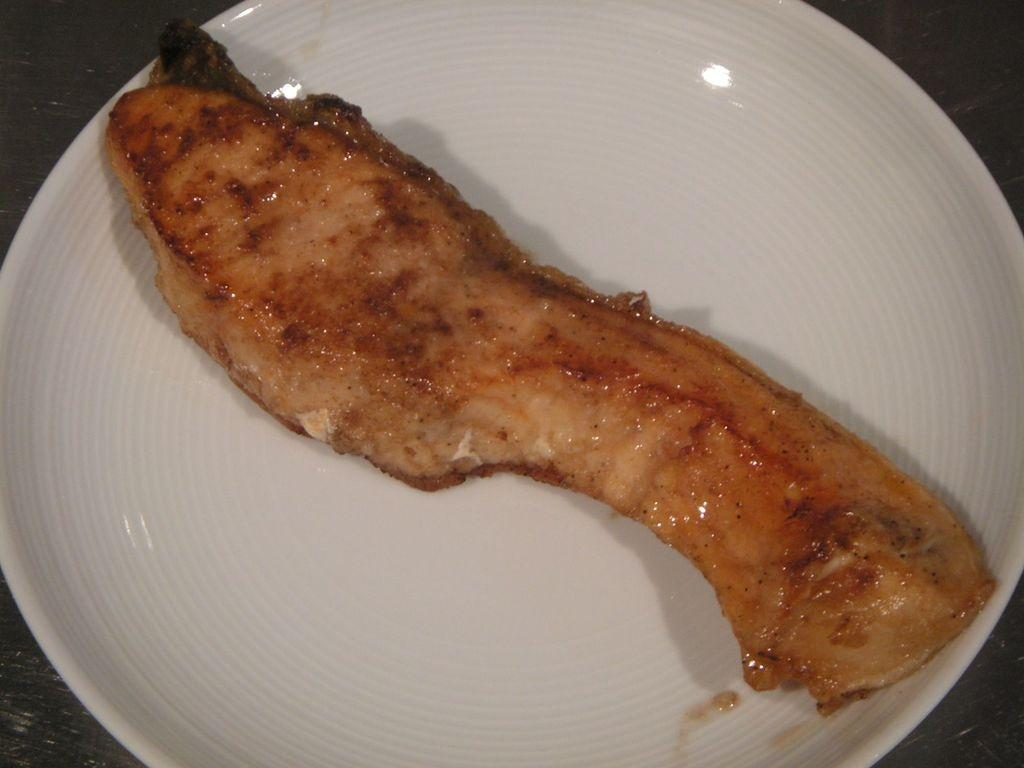What is on the plate in the image? There is a food item on a plate in the image. What color is the plate? The plate is white in color. What is the color of the surface the plate is on? The plate is on a dark color surface. How many stockings are hanging from the table in the image? There are no stockings or tables present in the image. 